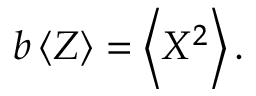Convert formula to latex. <formula><loc_0><loc_0><loc_500><loc_500>b \left < Z \right > = \left < X ^ { 2 } \right > .</formula> 